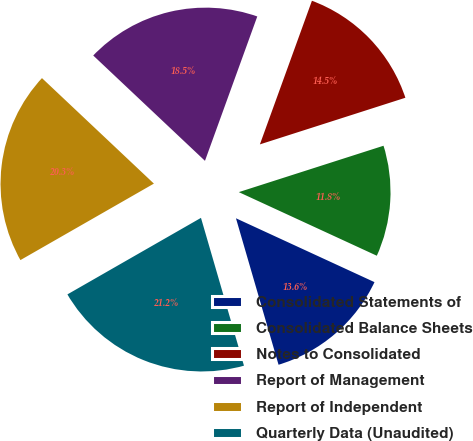Convert chart. <chart><loc_0><loc_0><loc_500><loc_500><pie_chart><fcel>Consolidated Statements of<fcel>Consolidated Balance Sheets<fcel>Notes to Consolidated<fcel>Report of Management<fcel>Report of Independent<fcel>Quarterly Data (Unaudited)<nl><fcel>13.62%<fcel>11.81%<fcel>14.53%<fcel>18.5%<fcel>20.31%<fcel>21.22%<nl></chart> 